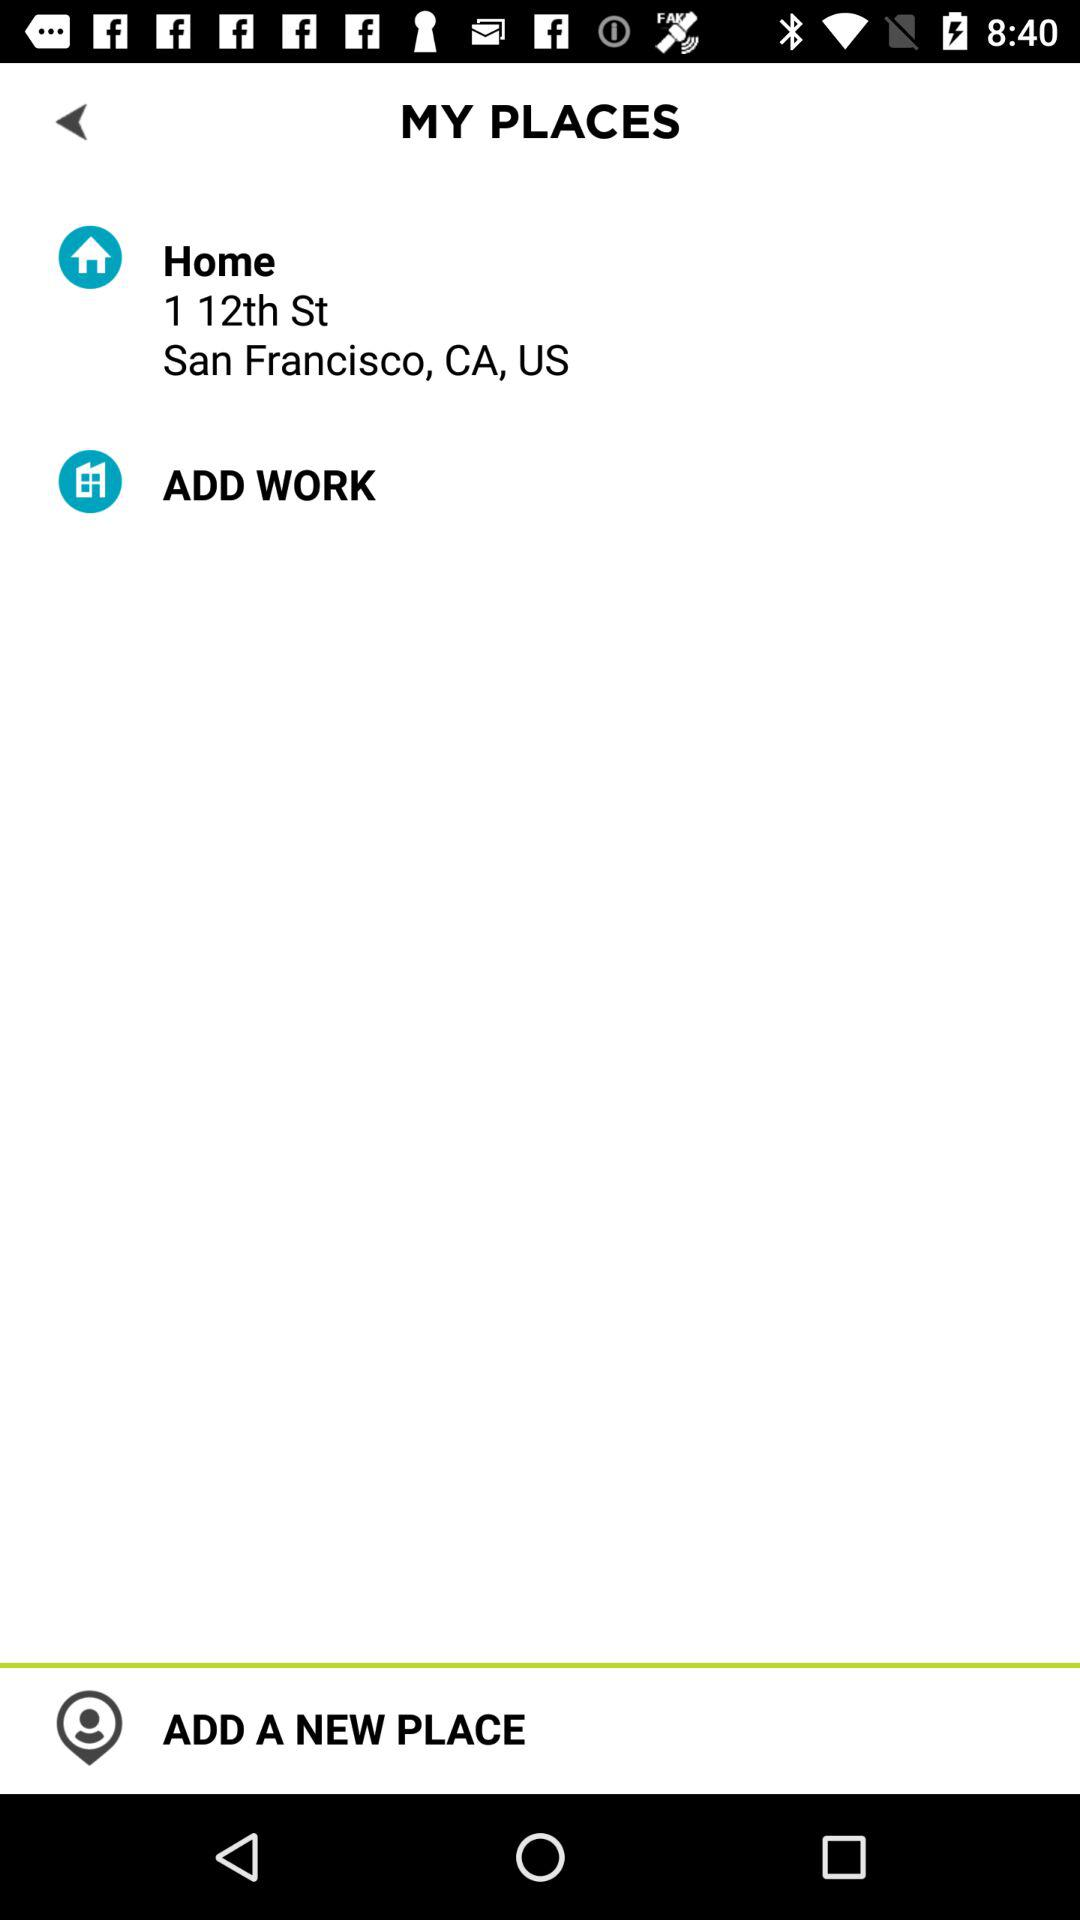What is the address of the user's work?
When the provided information is insufficient, respond with <no answer>. <no answer> 